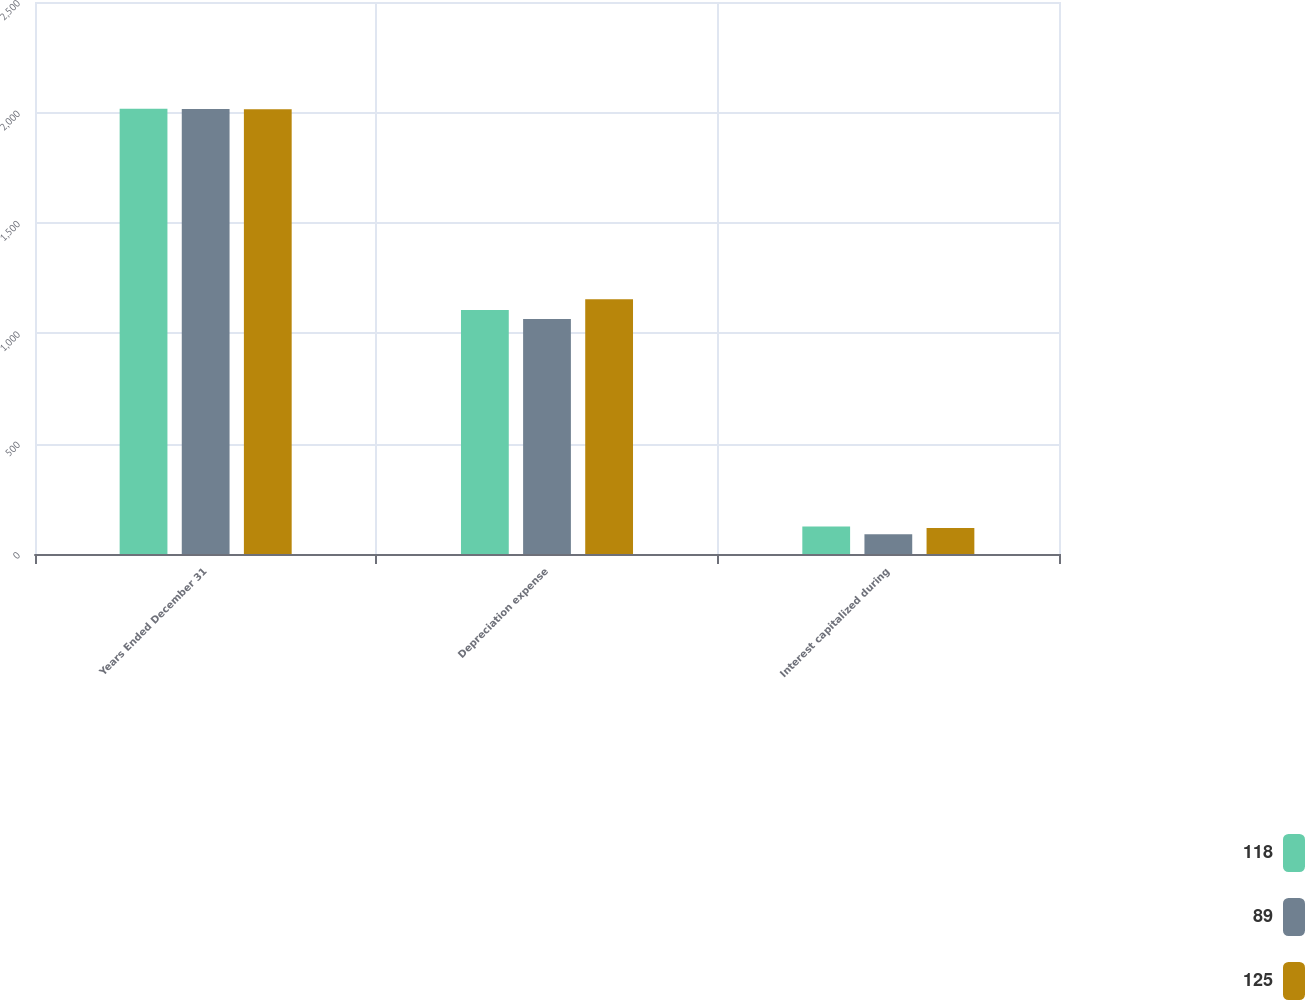<chart> <loc_0><loc_0><loc_500><loc_500><stacked_bar_chart><ecel><fcel>Years Ended December 31<fcel>Depreciation expense<fcel>Interest capitalized during<nl><fcel>118<fcel>2016<fcel>1105<fcel>125<nl><fcel>89<fcel>2015<fcel>1064<fcel>89<nl><fcel>125<fcel>2014<fcel>1154<fcel>118<nl></chart> 